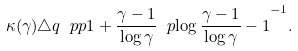<formula> <loc_0><loc_0><loc_500><loc_500>\kappa ( \gamma ) \triangle q \ p p { 1 + \frac { \gamma - 1 } { \log \gamma } \ p { \log \frac { \gamma - 1 } { \log \gamma } - 1 } } ^ { - 1 } .</formula> 